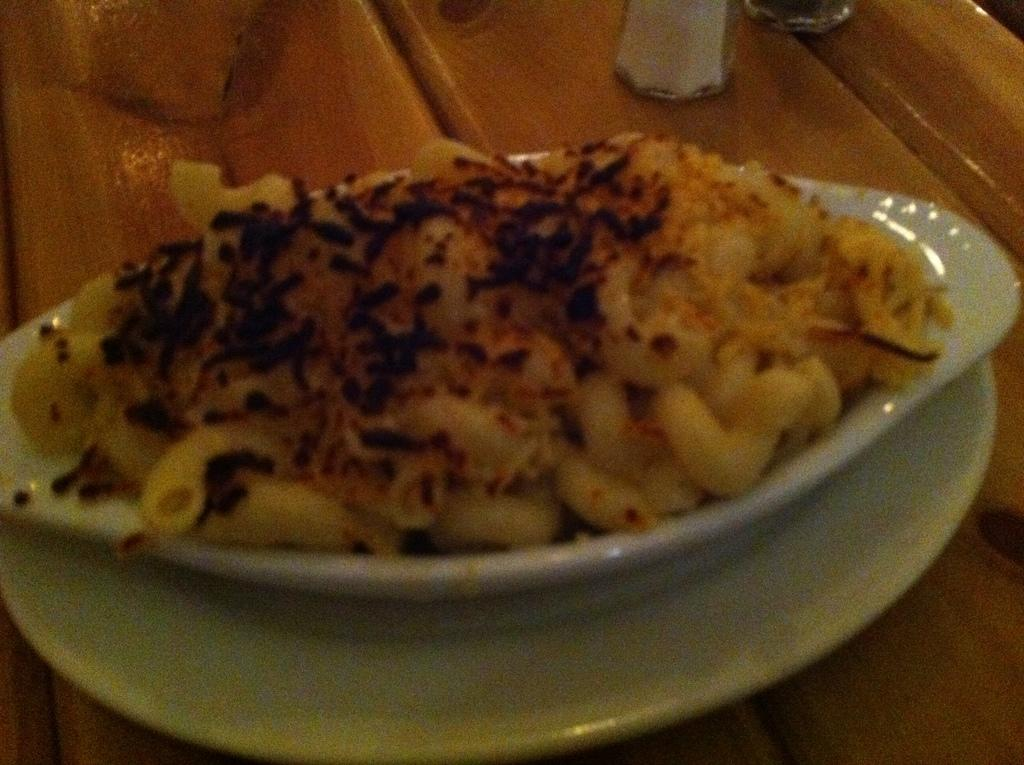What type of food is visible in the image? There is pasta in the image. What is the color of the dish containing the pasta? The pasta is in a white color dish. What breed of dog can be seen playing with the pasta in the image? There is no dog present in the image, and the pasta is not being played with. 